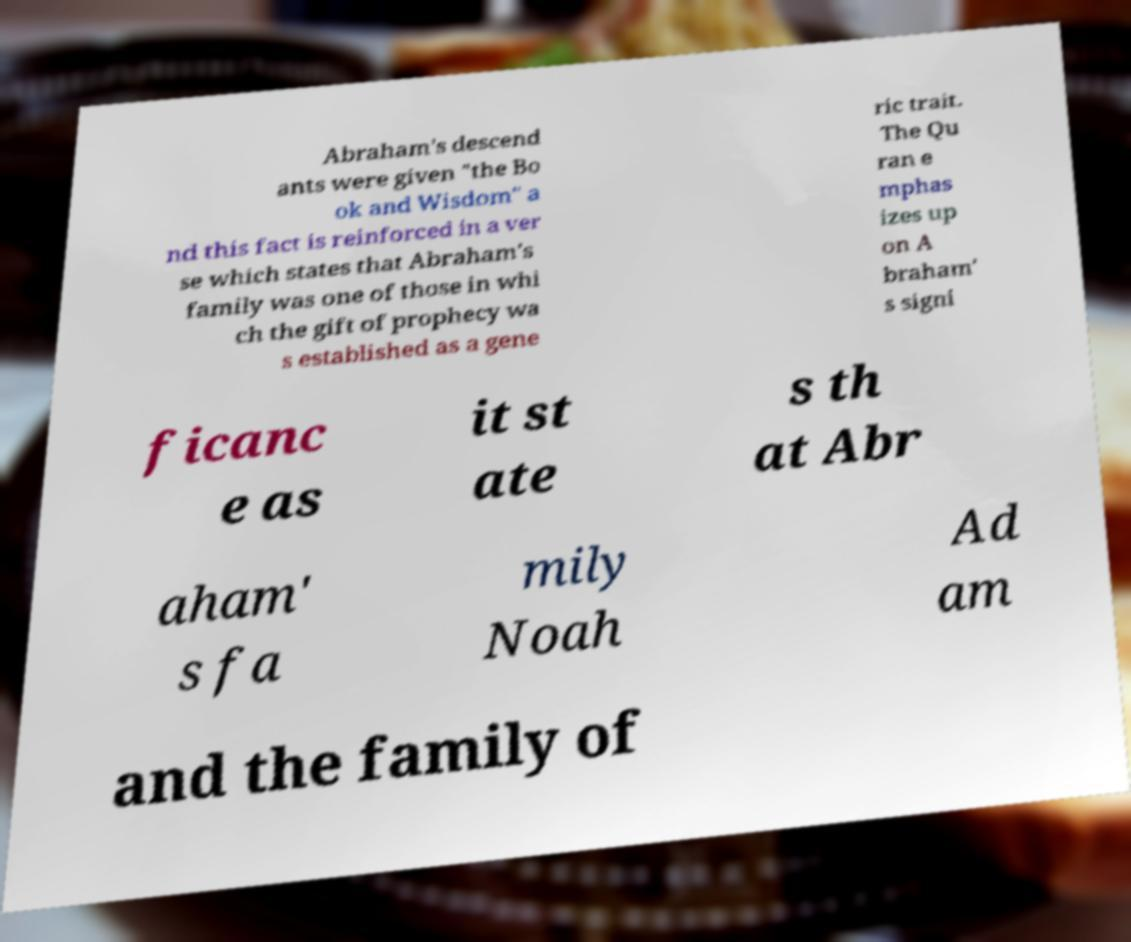Please read and relay the text visible in this image. What does it say? Abraham's descend ants were given "the Bo ok and Wisdom" a nd this fact is reinforced in a ver se which states that Abraham's family was one of those in whi ch the gift of prophecy wa s established as a gene ric trait. The Qu ran e mphas izes up on A braham' s signi ficanc e as it st ate s th at Abr aham' s fa mily Noah Ad am and the family of 